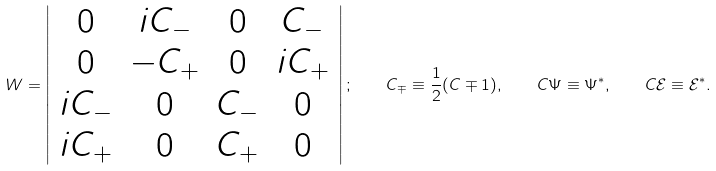<formula> <loc_0><loc_0><loc_500><loc_500>W = \left | \begin{array} { c c c c } 0 & i C _ { - } & 0 & C _ { - } \\ 0 & - C _ { + } & 0 & i C _ { + } \\ i C _ { - } & 0 & C _ { - } & 0 \\ i C _ { + } & 0 & C _ { + } & 0 \end{array} \right | ; \quad C _ { \mp } \equiv \frac { 1 } { 2 } ( C \mp 1 ) , \quad C \Psi \equiv \Psi ^ { * } , \quad C \mathcal { E } \equiv \mathcal { E } ^ { * } .</formula> 